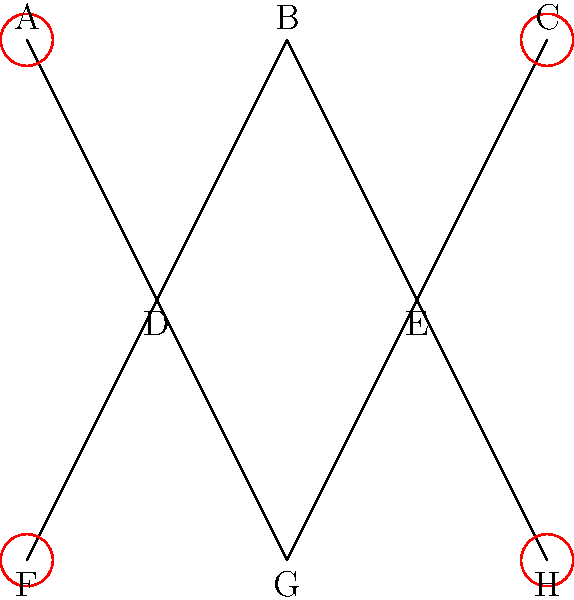In the family tree diagram above, circles indicate family members with reported behavioral issues. Based on this information and your expertise in child psychology, which family dynamic pattern is most likely present, and what potential intervention would you recommend? To analyze this family tree and identify the most likely family dynamic pattern, let's follow these steps:

1. Observe the structure:
   - Three generations are represented (A, B, C | D, E | F, G, H)
   - D and E appear to be siblings and the children of A, B, and C
   - F, G, and H are likely the children of D and E

2. Note the distribution of behavioral issues:
   - A and C (first generation) have reported issues
   - F and H (third generation) have reported issues
   - No issues are reported for the middle generation (D and E)

3. Analyze the pattern:
   - The behavioral issues seem to skip a generation
   - This suggests a potential intergenerational transmission of behavioral patterns

4. Identify the likely family dynamic:
   - The pattern indicates a possible "Legacy of Dysfunction" or "Intergenerational Transmission of Trauma"
   - The middle generation (D and E) may be overcompensating for their parents' issues, leading to problems in their children

5. Consider potential interventions:
   - Family systems therapy to address intergenerational patterns
   - Parenting skills training for D and E to help them balance their approach
   - Individual therapy for A, C, F, and H to address their specific behavioral issues
   - Psychoeducation for the entire family about intergenerational transmission of behaviors

Based on this analysis, the most appropriate intervention would be a combination of family systems therapy and individual counseling to address both the systemic issues and individual behavioral problems.
Answer: Intergenerational transmission of dysfunction; family systems therapy and individual counseling 